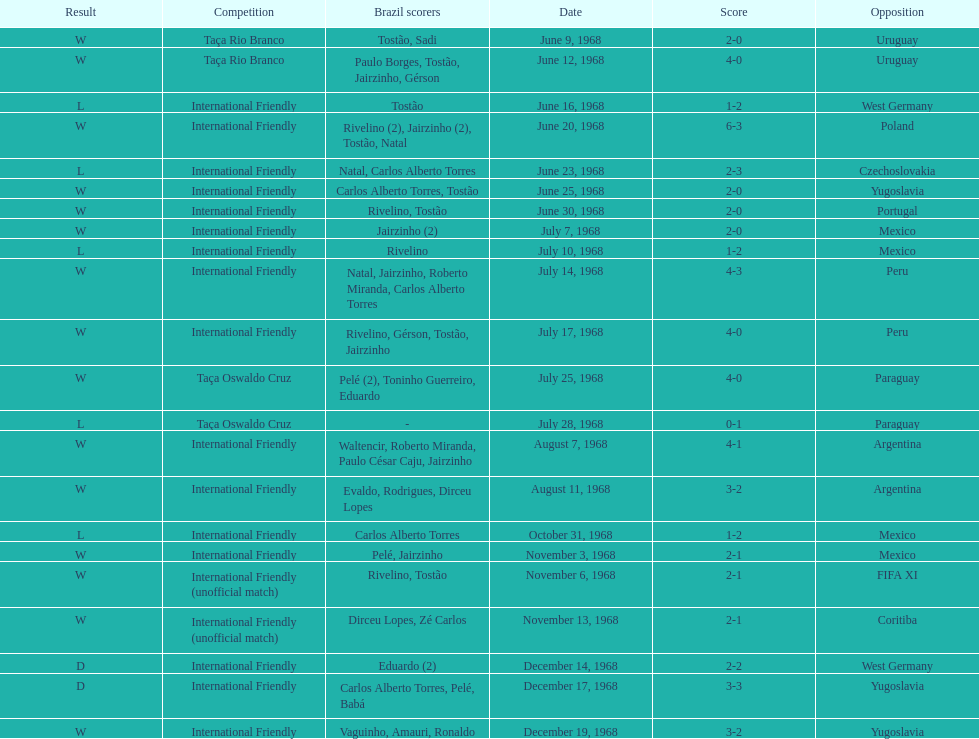How many times did brazil play against argentina in the international friendly competition? 2. 